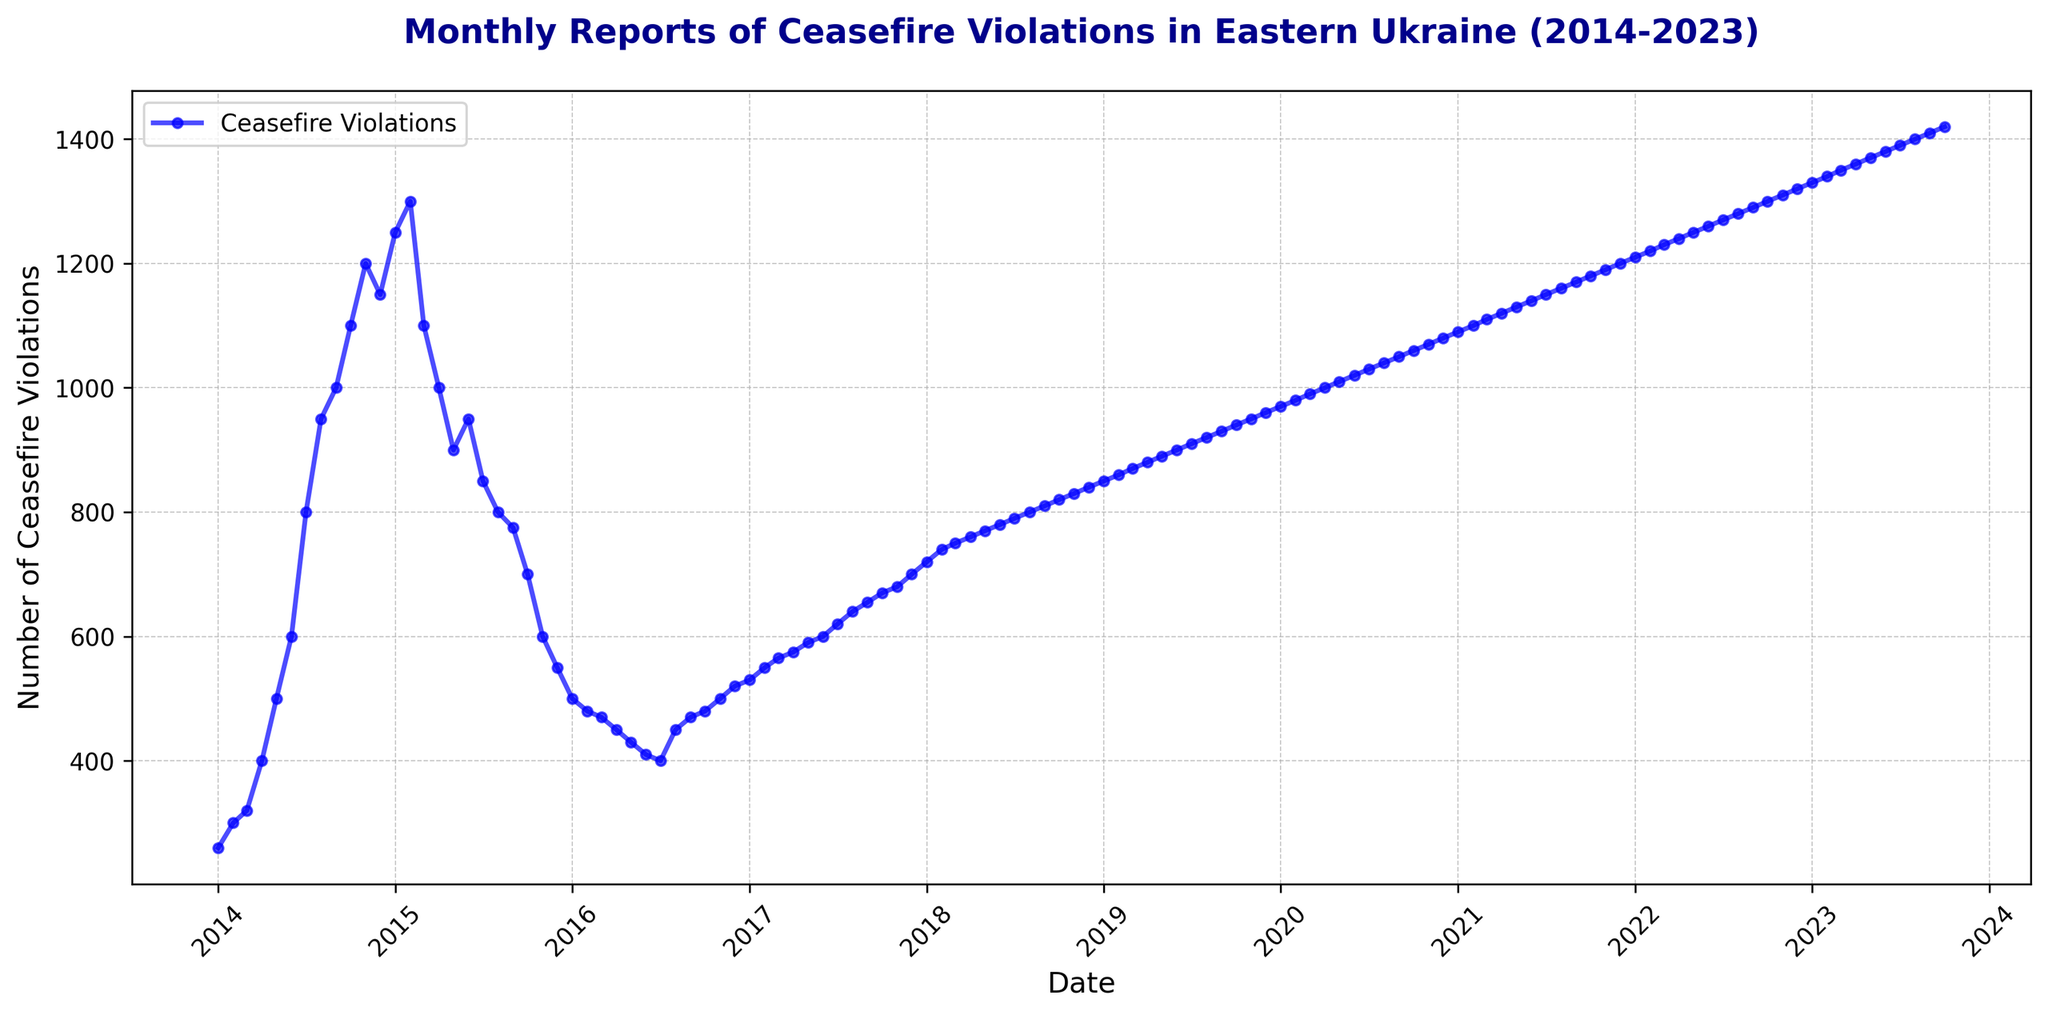What month and year had the highest number of ceasefire violations? By examining the graph, you can see that the peak of ceasefire violations occurred in October 2023. Follow the trend line to identify the specific data point that marks the highest value.
Answer: October 2023 How many times did the number of ceasefire violations decrease from one month to the next between January 2015 and December 2015? Look at the segment of the graph from January 2015 to December 2015 and count the downward slopes indicating decreases. There are six downward slopes.
Answer: 6 What is the average number of ceasefire violations from January 2014 to December 2014? Extract the monthly values for 2014 (260, 300, 320, 400, 500, 600, 800, 950, 1000, 1100, 1200, 1150). Sum these values to get 8580, then divide by 12 months. 8580 / 12 = 715.
Answer: 715 Compare the number of ceasefire violations before and after the peak in January 2015. How much did it change by January 2016? The peak in January 2015 is 1250 ceasefire violations. By January 2016, the number declined to 500. Calculate the difference: 1250 - 500 = 750.
Answer: 750 Which year experienced the most dramatic decrease in ceasefire violations, and by how much? Identify the year with the steepest downward slope in the graph. From January 2015 (1250) to December 2015 (500), the decrease was 1250 - 500 = 750, which is the most dramatic annual decline.
Answer: 2015, 750 How many years show an overall increasing trend in ceasefire violations from January to December? Observe the yearly segments, noting if the end value is higher than the start. Only the years 2019 to 2023 show a consistent increase, so 5 years show an overall increasing trend.
Answer: 5 Compare the ceasefire violations in July 2017 and July 2018. Which month had more violations and by what amount? July 2017 had 620 violations, and July 2018 had 790 violations. The difference is 790 - 620 = 170.
Answer: July 2018, 170 What visual indicator was used to mark the individual data points on the line chart? The line chart uses blue-colored circles (markers) at each data point to represent individual monthly data. This makes it easier to see each specific value clearly.
Answer: blue-colored circles 